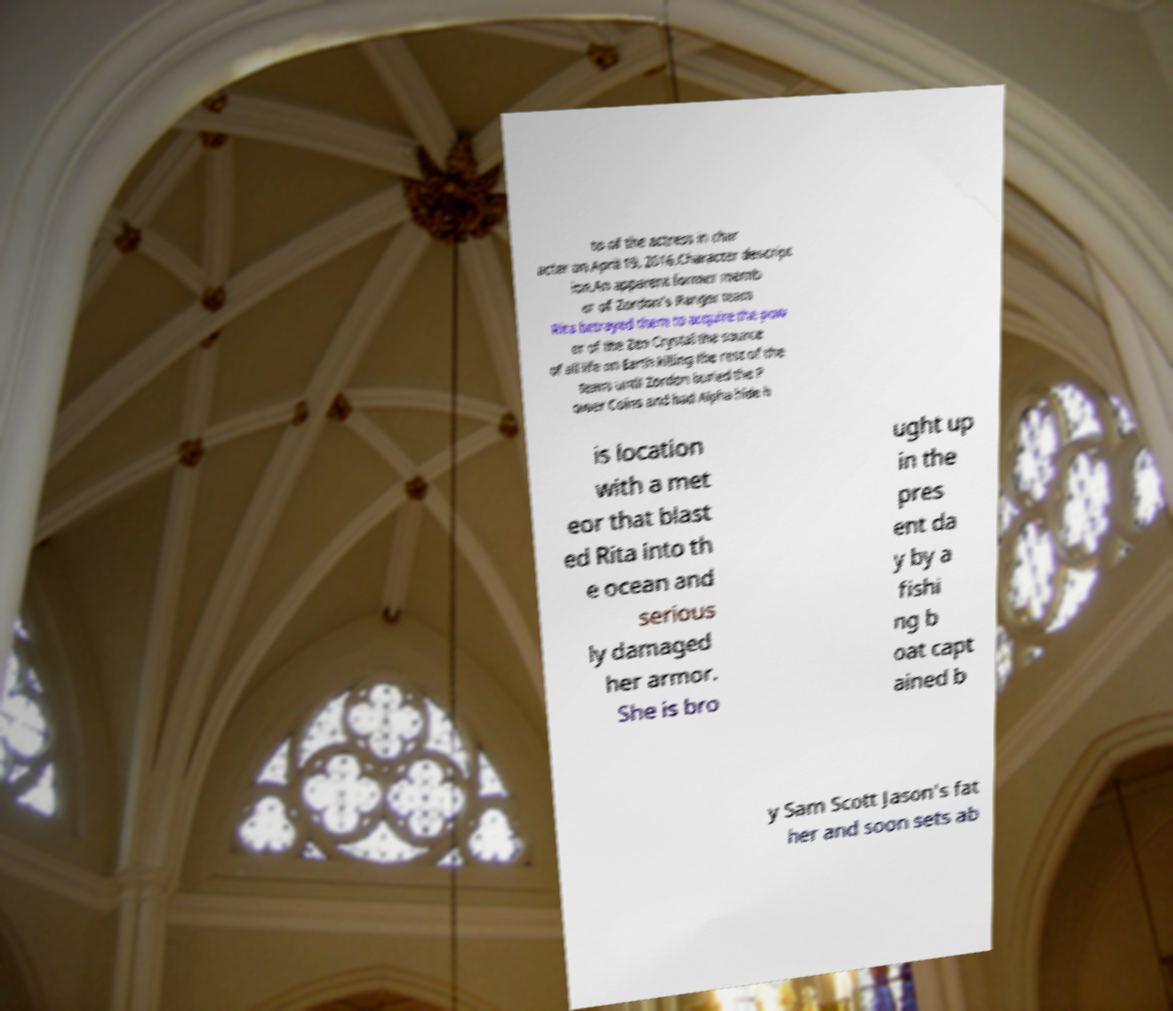Can you accurately transcribe the text from the provided image for me? to of the actress in char acter on April 19, 2016.Character descript ion.An apparent former memb er of Zordon's Ranger team Rita betrayed them to acquire the pow er of the Zeo Crystal the source of all life on Earth killing the rest of the team until Zordon buried the P ower Coins and had Alpha hide h is location with a met eor that blast ed Rita into th e ocean and serious ly damaged her armor. She is bro ught up in the pres ent da y by a fishi ng b oat capt ained b y Sam Scott Jason's fat her and soon sets ab 